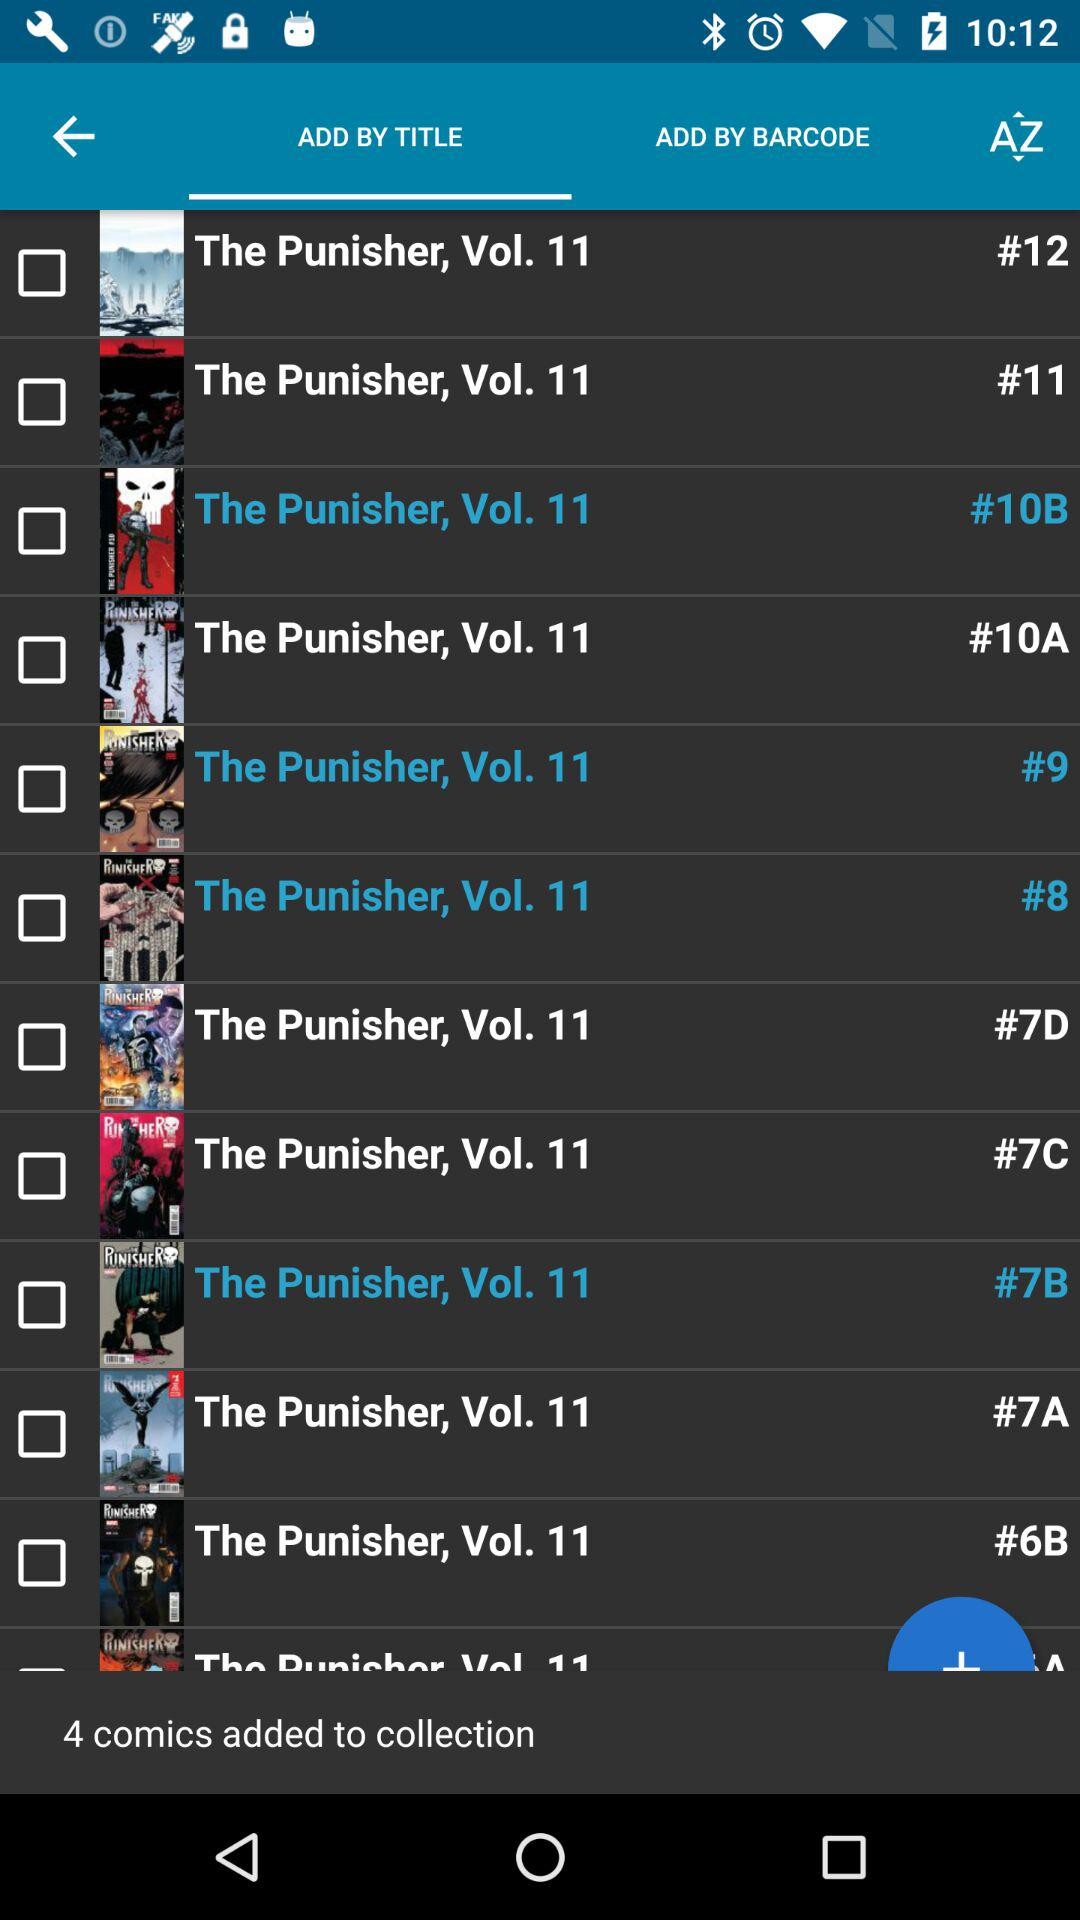How many comics are added to the collection? There are 4 comics added to the collection. 